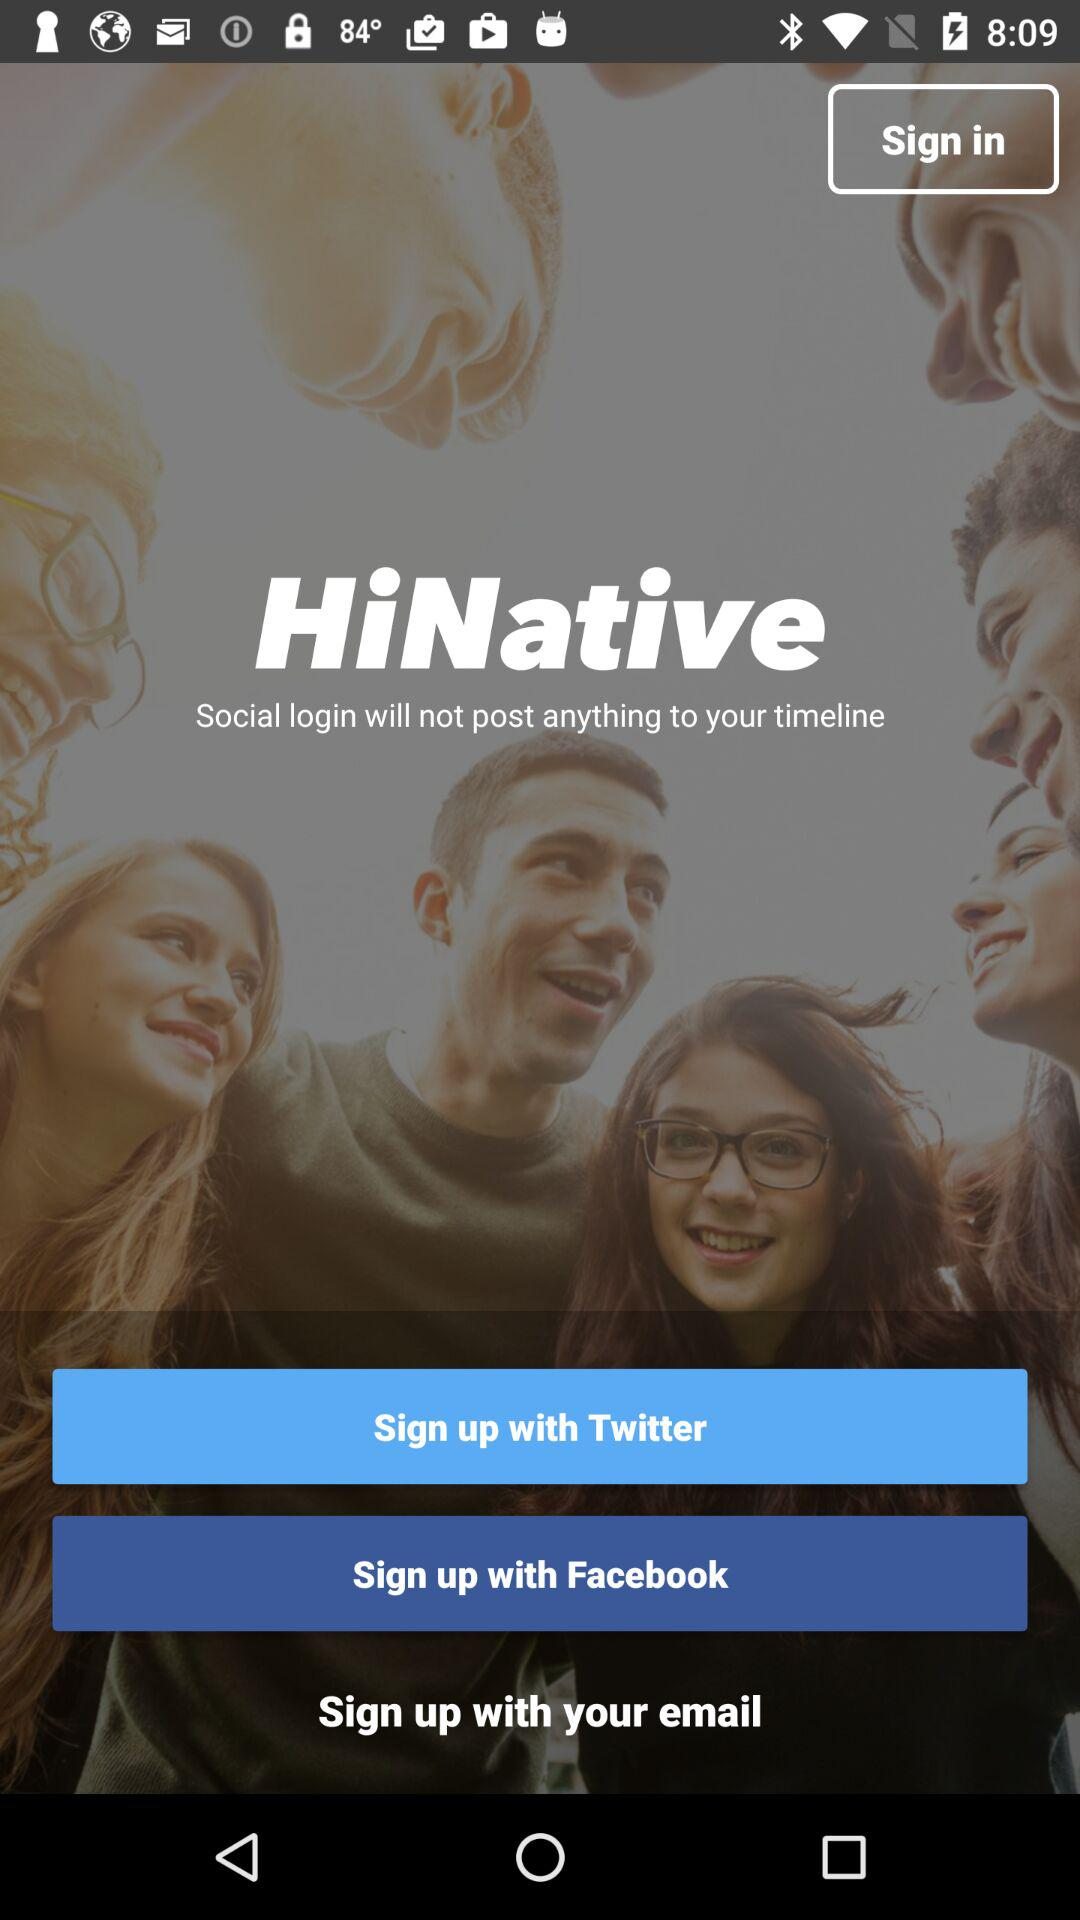What is the app name? The app name is "HiNative". 